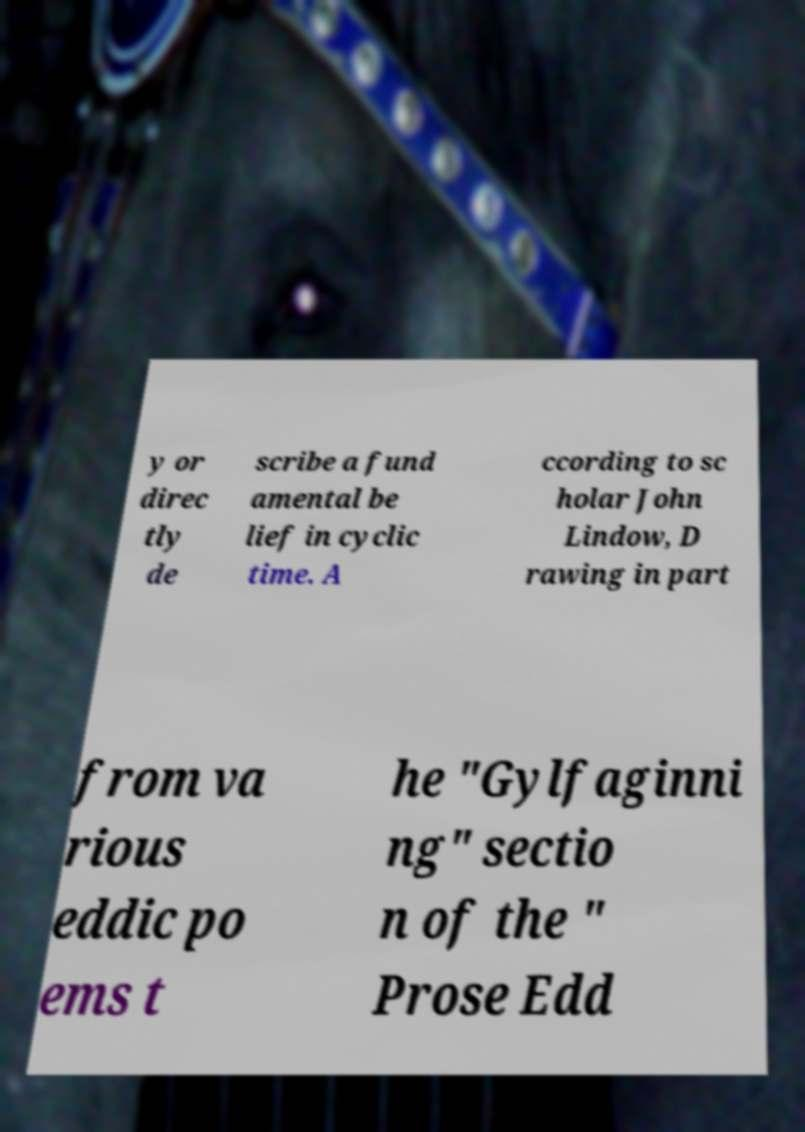There's text embedded in this image that I need extracted. Can you transcribe it verbatim? y or direc tly de scribe a fund amental be lief in cyclic time. A ccording to sc holar John Lindow, D rawing in part from va rious eddic po ems t he "Gylfaginni ng" sectio n of the " Prose Edd 